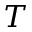Convert formula to latex. <formula><loc_0><loc_0><loc_500><loc_500>T</formula> 